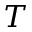Convert formula to latex. <formula><loc_0><loc_0><loc_500><loc_500>T</formula> 